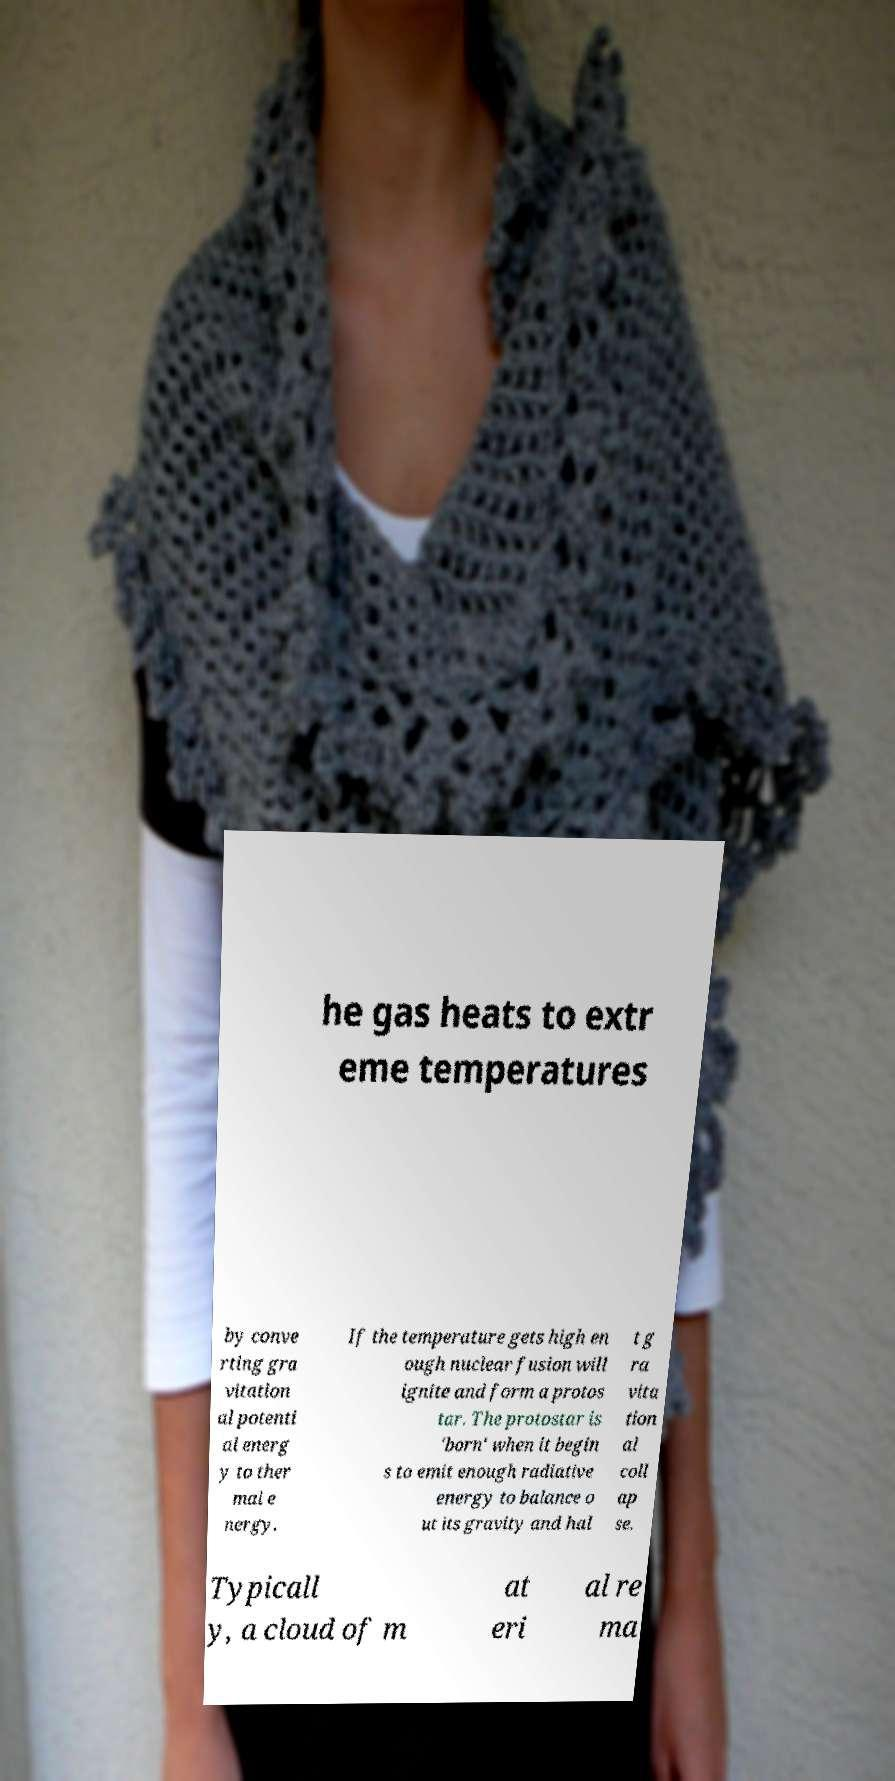There's text embedded in this image that I need extracted. Can you transcribe it verbatim? he gas heats to extr eme temperatures by conve rting gra vitation al potenti al energ y to ther mal e nergy. If the temperature gets high en ough nuclear fusion will ignite and form a protos tar. The protostar is 'born' when it begin s to emit enough radiative energy to balance o ut its gravity and hal t g ra vita tion al coll ap se. Typicall y, a cloud of m at eri al re ma 